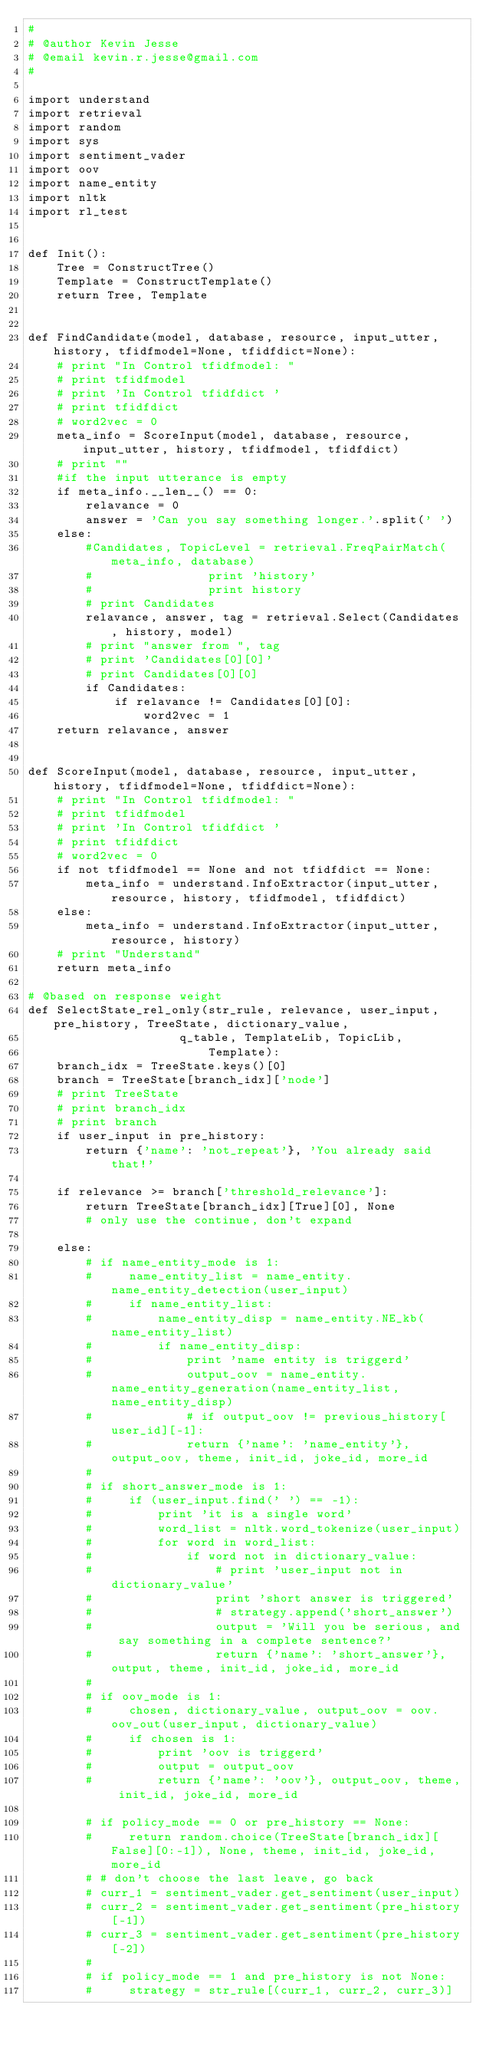Convert code to text. <code><loc_0><loc_0><loc_500><loc_500><_Python_>#
# @author Kevin Jesse
# @email kevin.r.jesse@gmail.com
#

import understand
import retrieval
import random
import sys
import sentiment_vader
import oov
import name_entity
import nltk
import rl_test


def Init():
    Tree = ConstructTree()
    Template = ConstructTemplate()
    return Tree, Template


def FindCandidate(model, database, resource, input_utter, history, tfidfmodel=None, tfidfdict=None):
    # print "In Control tfidfmodel: "
    # print tfidfmodel
    # print 'In Control tfidfdict '
    # print tfidfdict
    # word2vec = 0
    meta_info = ScoreInput(model, database, resource, input_utter, history, tfidfmodel, tfidfdict)
    # print ""
    #if the input utterance is empty
    if meta_info.__len__() == 0:
        relavance = 0
        answer = 'Can you say something longer.'.split(' ')
    else:
        #Candidates, TopicLevel = retrieval.FreqPairMatch(meta_info, database)
        #                print 'history'
        #                print history
        # print Candidates
        relavance, answer, tag = retrieval.Select(Candidates, history, model)
        # print "answer from ", tag
        # print 'Candidates[0][0]'
        # print Candidates[0][0]
        if Candidates:
            if relavance != Candidates[0][0]:
                word2vec = 1
    return relavance, answer


def ScoreInput(model, database, resource, input_utter, history, tfidfmodel=None, tfidfdict=None):
    # print "In Control tfidfmodel: "
    # print tfidfmodel
    # print 'In Control tfidfdict '
    # print tfidfdict
    # word2vec = 0
    if not tfidfmodel == None and not tfidfdict == None:
        meta_info = understand.InfoExtractor(input_utter, resource, history, tfidfmodel, tfidfdict)
    else:
        meta_info = understand.InfoExtractor(input_utter, resource, history)
    # print "Understand"
    return meta_info

# @based on response weight
def SelectState_rel_only(str_rule, relevance, user_input, pre_history, TreeState, dictionary_value,
                     q_table, TemplateLib, TopicLib,
                         Template):
    branch_idx = TreeState.keys()[0]
    branch = TreeState[branch_idx]['node']
    # print TreeState
    # print branch_idx
    # print branch
    if user_input in pre_history:
        return {'name': 'not_repeat'}, 'You already said that!'

    if relevance >= branch['threshold_relevance']:
        return TreeState[branch_idx][True][0], None
        # only use the continue, don't expand

    else:
        # if name_entity_mode is 1:
        #     name_entity_list = name_entity.name_entity_detection(user_input)
        #     if name_entity_list:
        #         name_entity_disp = name_entity.NE_kb(name_entity_list)
        #         if name_entity_disp:
        #             print 'name entity is triggerd'
        #             output_oov = name_entity.name_entity_generation(name_entity_list, name_entity_disp)
        #             # if output_oov != previous_history[user_id][-1]:
        #             return {'name': 'name_entity'}, output_oov, theme, init_id, joke_id, more_id
        #
        # if short_answer_mode is 1:
        #     if (user_input.find(' ') == -1):
        #         print 'it is a single word'
        #         word_list = nltk.word_tokenize(user_input)
        #         for word in word_list:
        #             if word not in dictionary_value:
        #                 # print 'user_input not in dictionary_value'
        #                 print 'short answer is triggered'
        #                 # strategy.append('short_answer')
        #                 output = 'Will you be serious, and say something in a complete sentence?'
        #                 return {'name': 'short_answer'}, output, theme, init_id, joke_id, more_id
        #
        # if oov_mode is 1:
        #     chosen, dictionary_value, output_oov = oov.oov_out(user_input, dictionary_value)
        #     if chosen is 1:
        #         print 'oov is triggerd'
        #         output = output_oov
        #         return {'name': 'oov'}, output_oov, theme, init_id, joke_id, more_id

        # if policy_mode == 0 or pre_history == None:
        #     return random.choice(TreeState[branch_idx][False][0:-1]), None, theme, init_id, joke_id, more_id
        # # don't choose the last leave, go back
        # curr_1 = sentiment_vader.get_sentiment(user_input)
        # curr_2 = sentiment_vader.get_sentiment(pre_history[-1])
        # curr_3 = sentiment_vader.get_sentiment(pre_history[-2])
        #
        # if policy_mode == 1 and pre_history is not None:
        #     strategy = str_rule[(curr_1, curr_2, curr_3)]</code> 